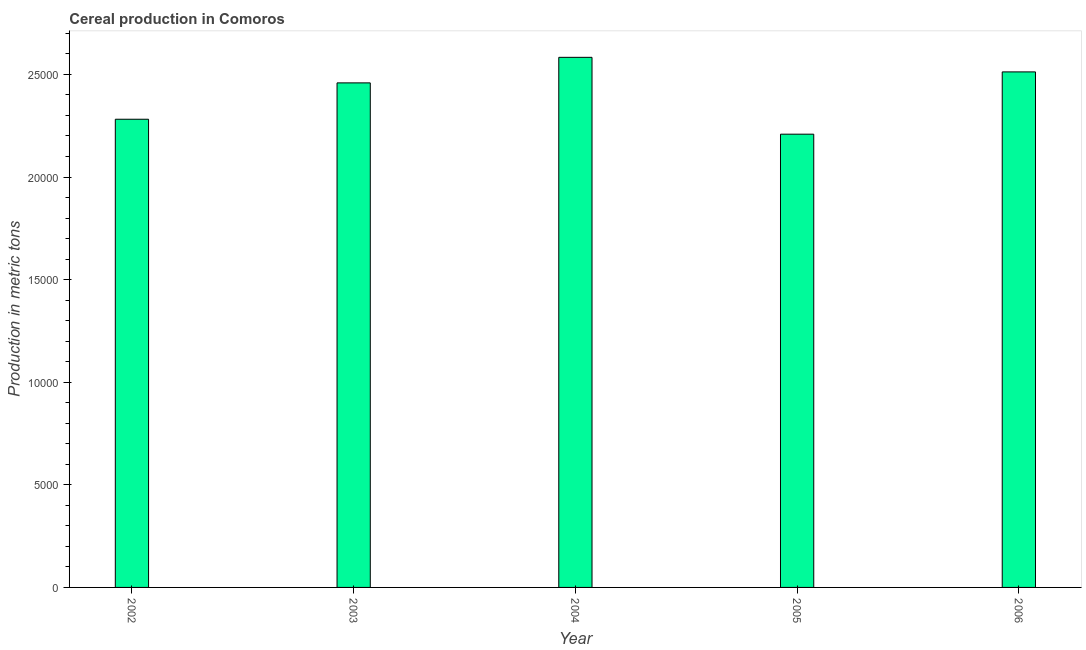Does the graph contain any zero values?
Provide a succinct answer. No. What is the title of the graph?
Keep it short and to the point. Cereal production in Comoros. What is the label or title of the Y-axis?
Your answer should be compact. Production in metric tons. What is the cereal production in 2004?
Ensure brevity in your answer.  2.58e+04. Across all years, what is the maximum cereal production?
Provide a succinct answer. 2.58e+04. Across all years, what is the minimum cereal production?
Your response must be concise. 2.21e+04. In which year was the cereal production maximum?
Offer a very short reply. 2004. What is the sum of the cereal production?
Give a very brief answer. 1.20e+05. What is the difference between the cereal production in 2004 and 2005?
Your response must be concise. 3745. What is the average cereal production per year?
Make the answer very short. 2.41e+04. What is the median cereal production?
Your response must be concise. 2.46e+04. In how many years, is the cereal production greater than 16000 metric tons?
Your answer should be very brief. 5. What is the ratio of the cereal production in 2003 to that in 2005?
Ensure brevity in your answer.  1.11. Is the difference between the cereal production in 2003 and 2004 greater than the difference between any two years?
Ensure brevity in your answer.  No. What is the difference between the highest and the second highest cereal production?
Provide a short and direct response. 710. What is the difference between the highest and the lowest cereal production?
Your answer should be compact. 3745. How many bars are there?
Offer a very short reply. 5. Are all the bars in the graph horizontal?
Your answer should be compact. No. How many years are there in the graph?
Offer a terse response. 5. What is the Production in metric tons in 2002?
Provide a succinct answer. 2.28e+04. What is the Production in metric tons of 2003?
Your answer should be compact. 2.46e+04. What is the Production in metric tons of 2004?
Give a very brief answer. 2.58e+04. What is the Production in metric tons in 2005?
Provide a succinct answer. 2.21e+04. What is the Production in metric tons of 2006?
Your answer should be compact. 2.51e+04. What is the difference between the Production in metric tons in 2002 and 2003?
Provide a short and direct response. -1772. What is the difference between the Production in metric tons in 2002 and 2004?
Ensure brevity in your answer.  -3017. What is the difference between the Production in metric tons in 2002 and 2005?
Keep it short and to the point. 728. What is the difference between the Production in metric tons in 2002 and 2006?
Keep it short and to the point. -2307. What is the difference between the Production in metric tons in 2003 and 2004?
Give a very brief answer. -1245. What is the difference between the Production in metric tons in 2003 and 2005?
Ensure brevity in your answer.  2500. What is the difference between the Production in metric tons in 2003 and 2006?
Your answer should be compact. -535. What is the difference between the Production in metric tons in 2004 and 2005?
Your answer should be compact. 3745. What is the difference between the Production in metric tons in 2004 and 2006?
Ensure brevity in your answer.  710. What is the difference between the Production in metric tons in 2005 and 2006?
Give a very brief answer. -3035. What is the ratio of the Production in metric tons in 2002 to that in 2003?
Provide a short and direct response. 0.93. What is the ratio of the Production in metric tons in 2002 to that in 2004?
Offer a very short reply. 0.88. What is the ratio of the Production in metric tons in 2002 to that in 2005?
Your answer should be very brief. 1.03. What is the ratio of the Production in metric tons in 2002 to that in 2006?
Your response must be concise. 0.91. What is the ratio of the Production in metric tons in 2003 to that in 2004?
Give a very brief answer. 0.95. What is the ratio of the Production in metric tons in 2003 to that in 2005?
Make the answer very short. 1.11. What is the ratio of the Production in metric tons in 2004 to that in 2005?
Provide a succinct answer. 1.17. What is the ratio of the Production in metric tons in 2004 to that in 2006?
Ensure brevity in your answer.  1.03. What is the ratio of the Production in metric tons in 2005 to that in 2006?
Your answer should be very brief. 0.88. 